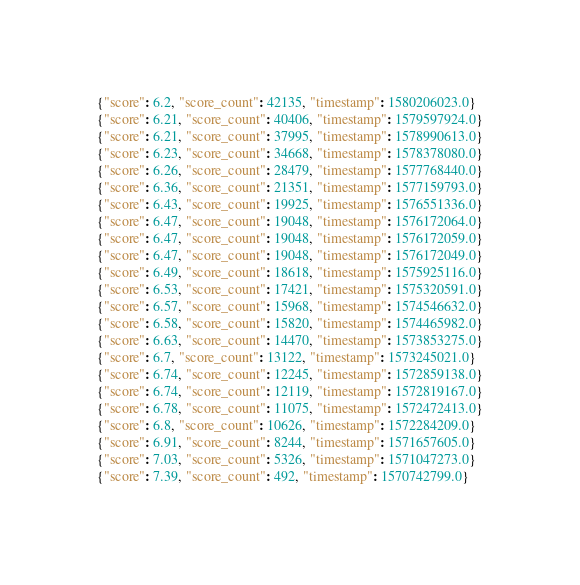Convert code to text. <code><loc_0><loc_0><loc_500><loc_500><_Julia_>{"score": 6.2, "score_count": 42135, "timestamp": 1580206023.0}
{"score": 6.21, "score_count": 40406, "timestamp": 1579597924.0}
{"score": 6.21, "score_count": 37995, "timestamp": 1578990613.0}
{"score": 6.23, "score_count": 34668, "timestamp": 1578378080.0}
{"score": 6.26, "score_count": 28479, "timestamp": 1577768440.0}
{"score": 6.36, "score_count": 21351, "timestamp": 1577159793.0}
{"score": 6.43, "score_count": 19925, "timestamp": 1576551336.0}
{"score": 6.47, "score_count": 19048, "timestamp": 1576172064.0}
{"score": 6.47, "score_count": 19048, "timestamp": 1576172059.0}
{"score": 6.47, "score_count": 19048, "timestamp": 1576172049.0}
{"score": 6.49, "score_count": 18618, "timestamp": 1575925116.0}
{"score": 6.53, "score_count": 17421, "timestamp": 1575320591.0}
{"score": 6.57, "score_count": 15968, "timestamp": 1574546632.0}
{"score": 6.58, "score_count": 15820, "timestamp": 1574465982.0}
{"score": 6.63, "score_count": 14470, "timestamp": 1573853275.0}
{"score": 6.7, "score_count": 13122, "timestamp": 1573245021.0}
{"score": 6.74, "score_count": 12245, "timestamp": 1572859138.0}
{"score": 6.74, "score_count": 12119, "timestamp": 1572819167.0}
{"score": 6.78, "score_count": 11075, "timestamp": 1572472413.0}
{"score": 6.8, "score_count": 10626, "timestamp": 1572284209.0}
{"score": 6.91, "score_count": 8244, "timestamp": 1571657605.0}
{"score": 7.03, "score_count": 5326, "timestamp": 1571047273.0}
{"score": 7.39, "score_count": 492, "timestamp": 1570742799.0}
</code> 